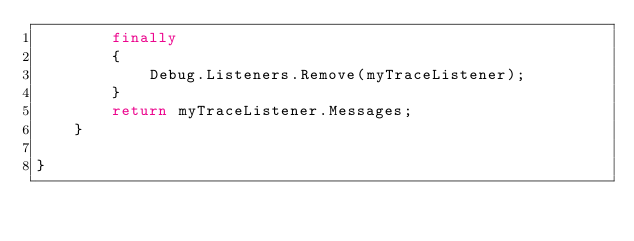Convert code to text. <code><loc_0><loc_0><loc_500><loc_500><_C#_>        finally
        {
            Debug.Listeners.Remove(myTraceListener);
        }
        return myTraceListener.Messages;
    }

}</code> 